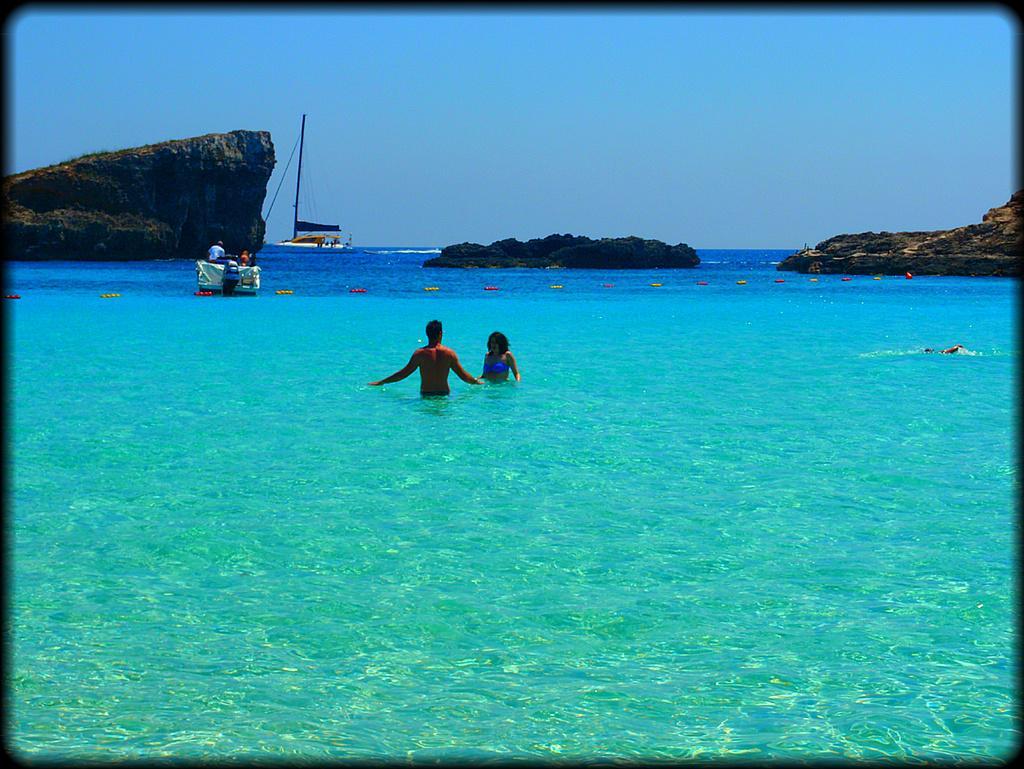Please provide a concise description of this image. In this image we can see few people swimming in the water and there are two boats and few people in a boat, there is a mountain and an island with trees and sky in the background. 